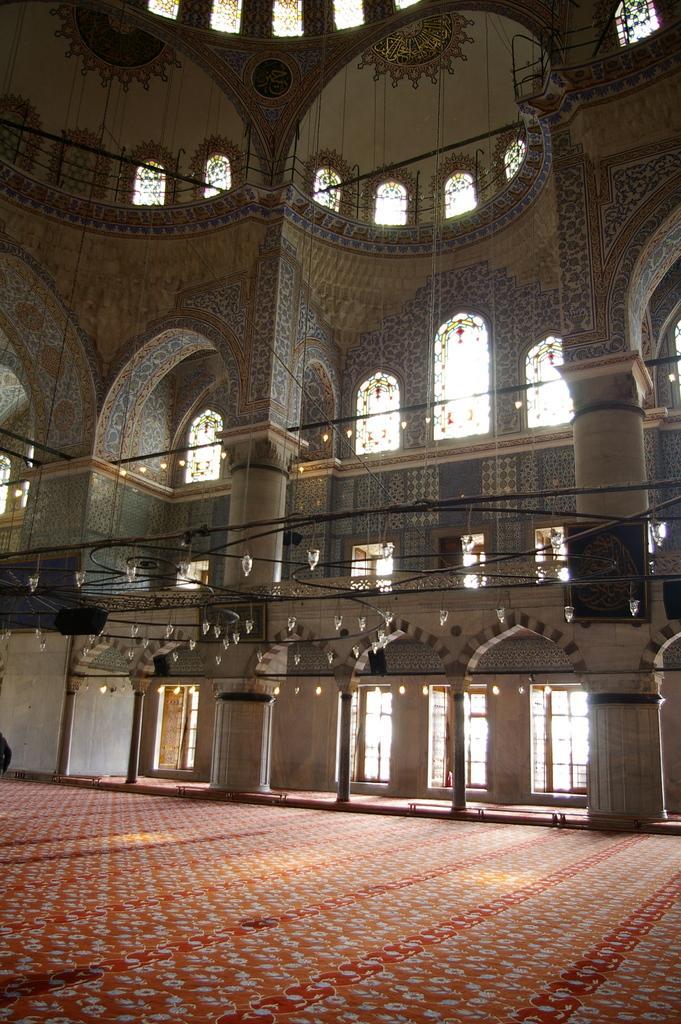Can you describe this image briefly? This picture describes about inside of the building, in this we can find few cables and lights. 